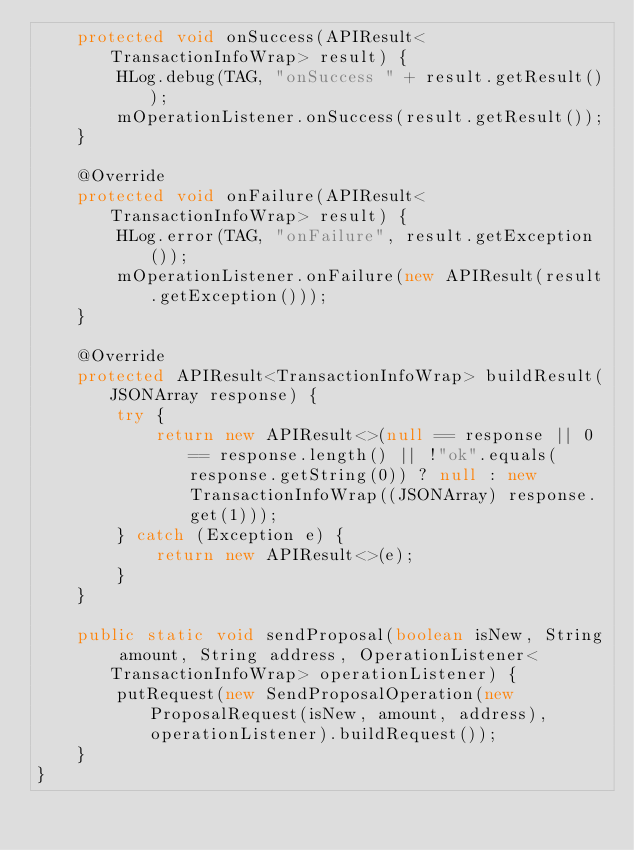Convert code to text. <code><loc_0><loc_0><loc_500><loc_500><_Java_>    protected void onSuccess(APIResult<TransactionInfoWrap> result) {
        HLog.debug(TAG, "onSuccess " + result.getResult());
        mOperationListener.onSuccess(result.getResult());
    }

    @Override
    protected void onFailure(APIResult<TransactionInfoWrap> result) {
        HLog.error(TAG, "onFailure", result.getException());
        mOperationListener.onFailure(new APIResult(result.getException()));
    }

    @Override
    protected APIResult<TransactionInfoWrap> buildResult(JSONArray response) {
        try {
            return new APIResult<>(null == response || 0 == response.length() || !"ok".equals(response.getString(0)) ? null : new TransactionInfoWrap((JSONArray) response.get(1)));
        } catch (Exception e) {
            return new APIResult<>(e);
        }
    }

    public static void sendProposal(boolean isNew, String amount, String address, OperationListener<TransactionInfoWrap> operationListener) {
        putRequest(new SendProposalOperation(new ProposalRequest(isNew, amount, address), operationListener).buildRequest());
    }
}</code> 